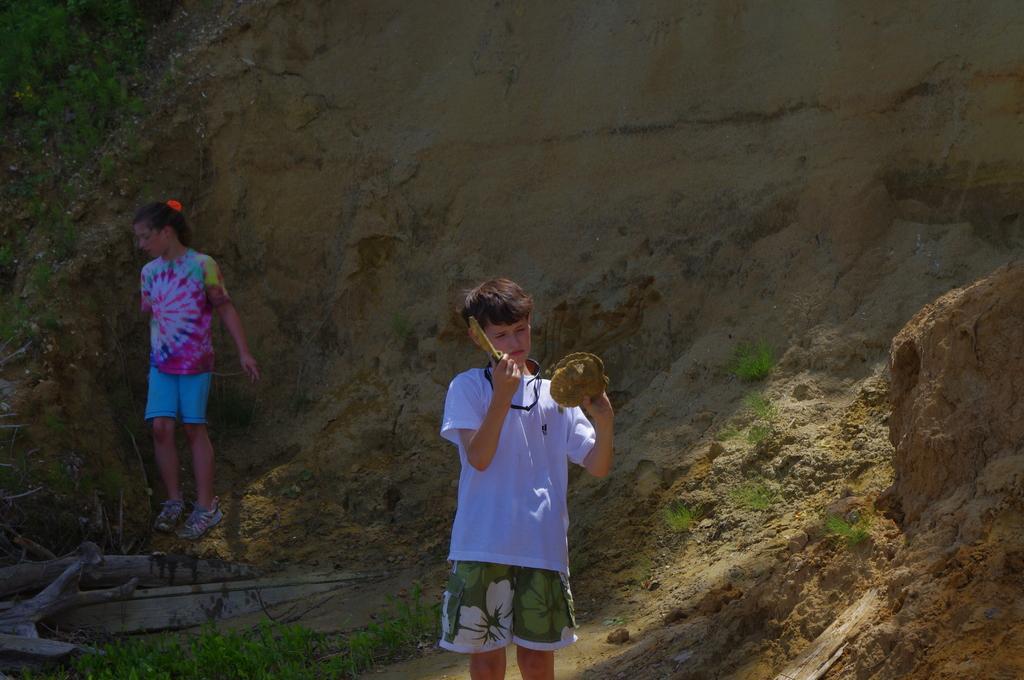Please provide a concise description of this image. In this picture there is a boy standing and holding the object and there is a girl standing and there are plants and tree branches and there is grass. At the back it looks like a mountain. 